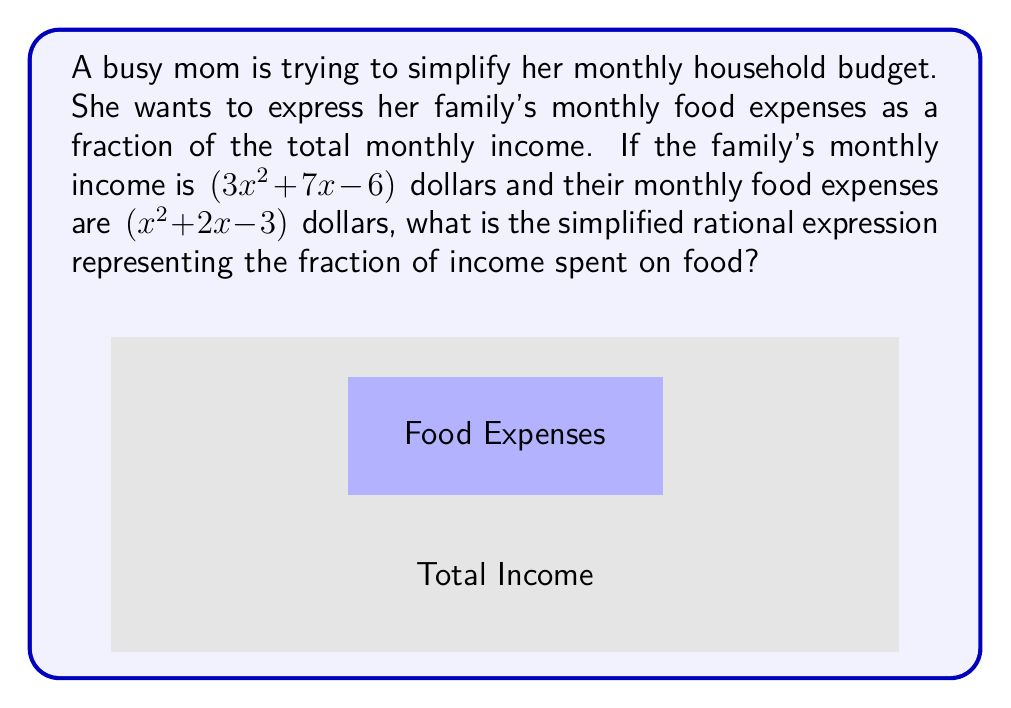Help me with this question. Let's approach this step-by-step:

1) The fraction of income spent on food is represented by:

   $$\frac{\text{Food Expenses}}{\text{Total Income}} = \frac{x^2 + 2x - 3}{3x^2 + 7x - 6}$$

2) To simplify this rational expression, we need to factor both the numerator and denominator:

   Numerator: $x^2 + 2x - 3 = (x+3)(x-1)$
   Denominator: $3x^2 + 7x - 6 = (3x-2)(x+3)$

3) Now our expression looks like:

   $$\frac{(x+3)(x-1)}{(3x-2)(x+3)}$$

4) We can cancel out the common factor $(x+3)$ in both numerator and denominator:

   $$\frac{(x-1)}{(3x-2)}$$

5) This fraction cannot be simplified further as there are no more common factors.
Answer: $$\frac{x-1}{3x-2}$$ 